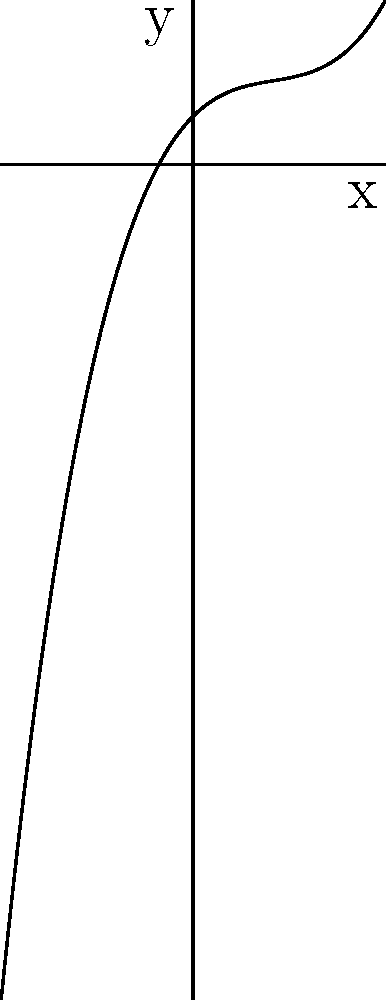As a junior software tester with expertise in automation testing, you're developing a test case for a graphing calculator application. The application should correctly identify the degree of polynomials based on their graphs. Given the graph above, what is the degree of the polynomial it represents? To determine the degree of a polynomial from its graph, we need to follow these steps:

1. Observe the end behavior of the graph (how it behaves as x approaches positive and negative infinity).
2. Count the number of turning points (local maxima and minima).
3. Use the following rules:
   - A polynomial of degree n will have at most n-1 turning points.
   - The end behavior of odd-degree polynomials is opposite on each end, while even-degree polynomials have the same end behavior on both ends.

Let's analyze this graph:

1. End behavior: As x approaches positive infinity, y approaches positive infinity. As x approaches negative infinity, y approaches negative infinity. This suggests an odd-degree polynomial.

2. Turning points: The graph has two turning points (one local maximum and one local minimum).

3. Applying the rules:
   - With two turning points, the degree must be at least 3.
   - The odd end behavior confirms that the degree is odd.
   - The smallest odd number that satisfies these conditions is 3.

Therefore, the polynomial represented by this graph is of degree 3 (cubic).
Answer: 3 